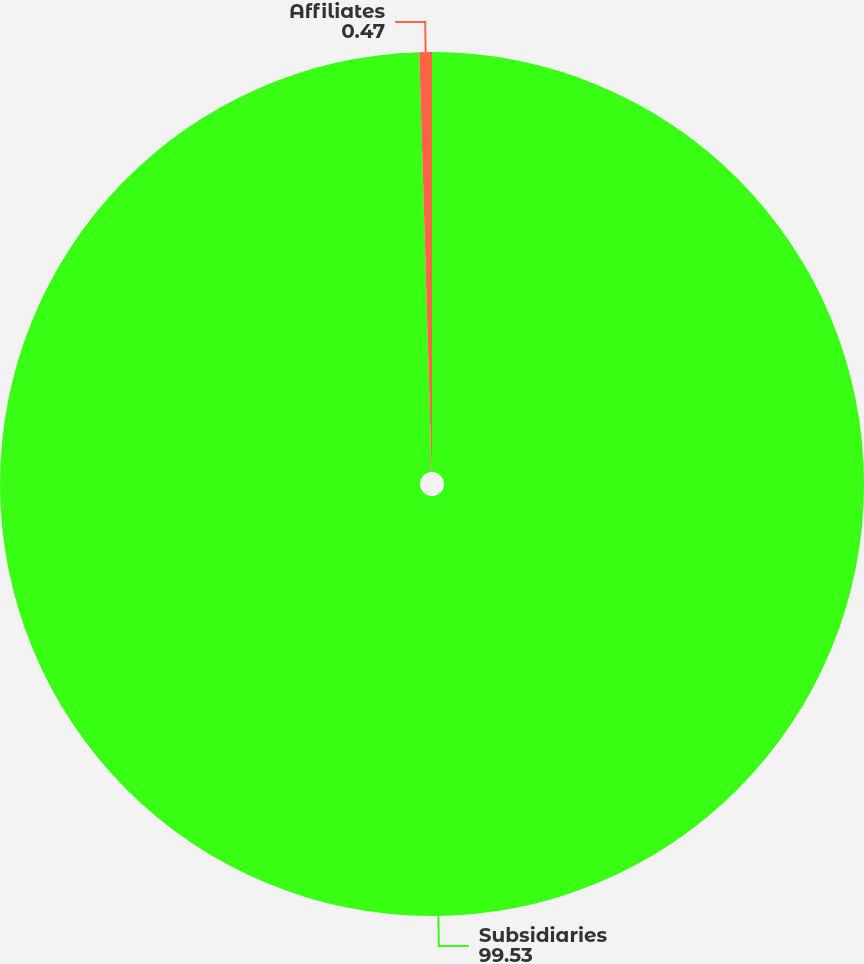<chart> <loc_0><loc_0><loc_500><loc_500><pie_chart><fcel>Subsidiaries<fcel>Affiliates<nl><fcel>99.53%<fcel>0.47%<nl></chart> 